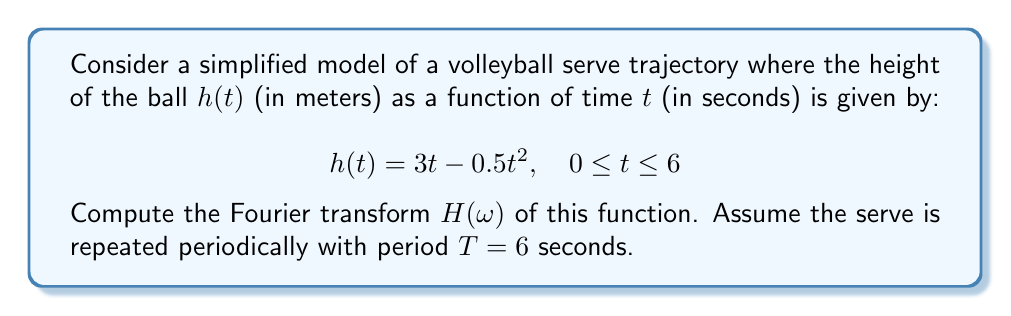Solve this math problem. Let's approach this step-by-step:

1) The Fourier transform of a periodic function with period $T$ is given by:

   $$H(\omega) = \frac{1}{T} \sum_{n=-\infty}^{\infty} c_n \delta(\omega - n\omega_0)$$

   where $\omega_0 = \frac{2\pi}{T}$ and $c_n$ are the Fourier series coefficients.

2) We need to find the Fourier series coefficients $c_n$:

   $$c_n = \frac{1}{T} \int_0^T h(t) e^{-in\omega_0 t} dt$$

3) Substituting our function and $T = 6$:

   $$c_n = \frac{1}{6} \int_0^6 (3t - 0.5t^2) e^{-in\pi t/3} dt$$

4) This integral can be solved using integration by parts. After calculation:

   $$c_n = \frac{18}{(n\pi)^2} - \frac{36i}{(n\pi)^3} \quad \text{for } n \neq 0$$

   $$c_0 = 3$$

5) Therefore, the Fourier transform is:

   $$H(\omega) = \frac{1}{2} \delta(\omega) + \frac{1}{6} \sum_{n \neq 0} \left(\frac{18}{(n\pi)^2} - \frac{36i}{(n\pi)^3}\right) \delta(\omega - n\frac{\pi}{3})$$

This expression represents the frequency components of the serve trajectory, with peaks at multiples of the fundamental frequency $\frac{\pi}{3}$ rad/s.
Answer: $$H(\omega) = \frac{1}{2} \delta(\omega) + \frac{1}{6} \sum_{n \neq 0} \left(\frac{18}{(n\pi)^2} - \frac{36i}{(n\pi)^3}\right) \delta(\omega - n\frac{\pi}{3})$$ 